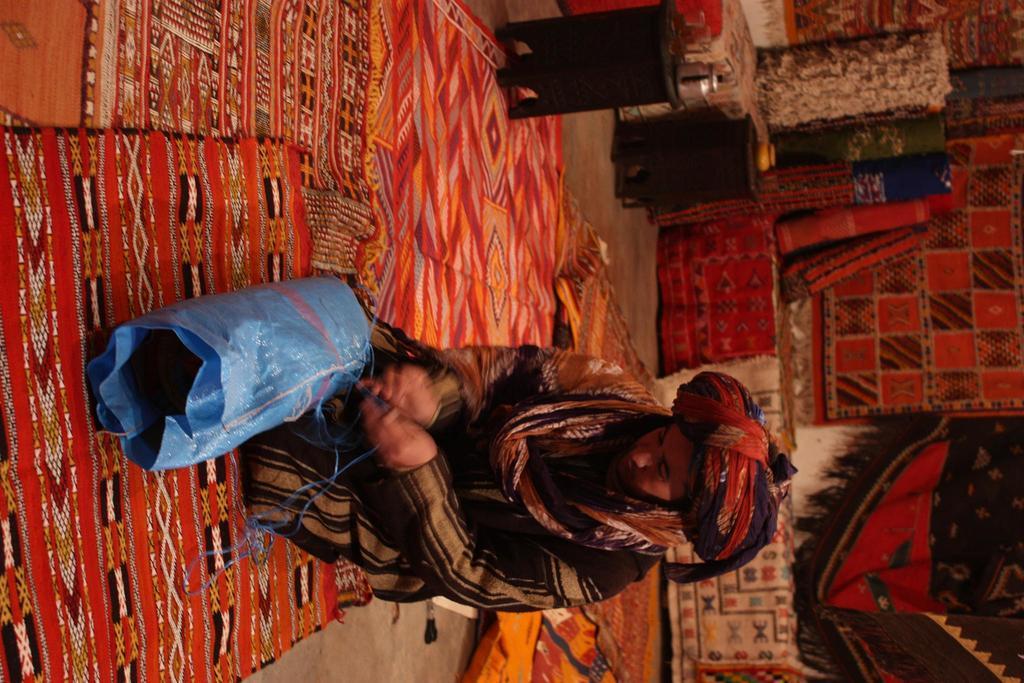How would you summarize this image in a sentence or two? In this image I can see the person and the person is wearing black and brown color dress and I can see few carpets in multicolor. 